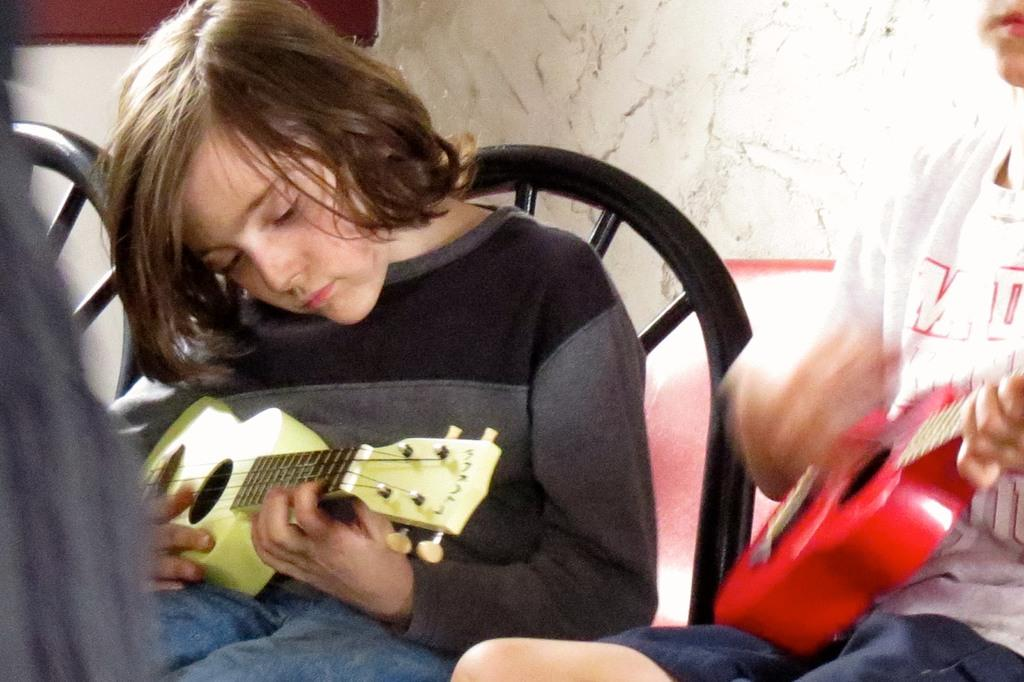What are the people in the image doing? There are people seated on chairs in the image, and two persons are playing guitar. How many people are playing guitar in the image? Two persons are playing guitar in the image. What type of cheese is being used as a toothpick by the person playing the guitar in the image? There is no cheese or toothpick present in the image; the people are playing guitar while seated on chairs. 